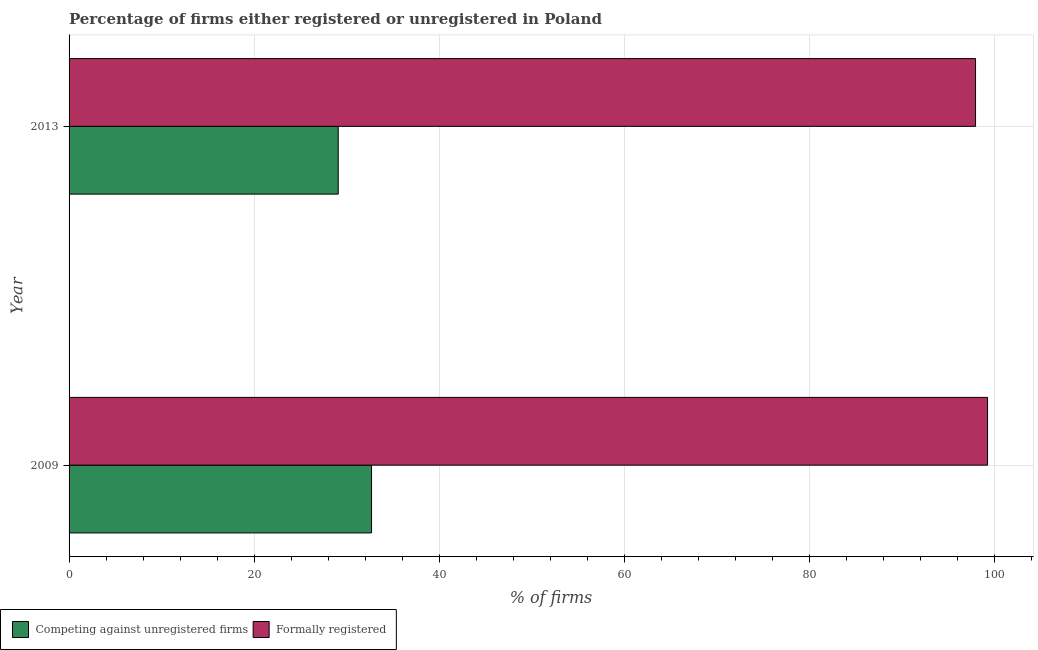How many different coloured bars are there?
Offer a terse response. 2. Are the number of bars on each tick of the Y-axis equal?
Offer a very short reply. Yes. How many bars are there on the 2nd tick from the top?
Your answer should be compact. 2. How many bars are there on the 1st tick from the bottom?
Your response must be concise. 2. In how many cases, is the number of bars for a given year not equal to the number of legend labels?
Provide a short and direct response. 0. What is the percentage of formally registered firms in 2009?
Offer a terse response. 99.3. Across all years, what is the maximum percentage of formally registered firms?
Offer a terse response. 99.3. In which year was the percentage of formally registered firms maximum?
Give a very brief answer. 2009. In which year was the percentage of formally registered firms minimum?
Keep it short and to the point. 2013. What is the total percentage of registered firms in the graph?
Make the answer very short. 61.8. What is the difference between the percentage of formally registered firms in 2009 and that in 2013?
Your answer should be very brief. 1.3. What is the difference between the percentage of formally registered firms in 2009 and the percentage of registered firms in 2013?
Your response must be concise. 70.2. What is the average percentage of formally registered firms per year?
Keep it short and to the point. 98.65. In the year 2009, what is the difference between the percentage of formally registered firms and percentage of registered firms?
Offer a terse response. 66.6. In how many years, is the percentage of formally registered firms greater than 64 %?
Give a very brief answer. 2. What is the ratio of the percentage of registered firms in 2009 to that in 2013?
Your answer should be compact. 1.12. What does the 1st bar from the top in 2013 represents?
Offer a terse response. Formally registered. What does the 2nd bar from the bottom in 2013 represents?
Offer a terse response. Formally registered. How many bars are there?
Keep it short and to the point. 4. Are all the bars in the graph horizontal?
Your answer should be very brief. Yes. What is the difference between two consecutive major ticks on the X-axis?
Give a very brief answer. 20. Does the graph contain grids?
Ensure brevity in your answer.  Yes. What is the title of the graph?
Your response must be concise. Percentage of firms either registered or unregistered in Poland. Does "Under-5(female)" appear as one of the legend labels in the graph?
Your answer should be compact. No. What is the label or title of the X-axis?
Provide a short and direct response. % of firms. What is the label or title of the Y-axis?
Keep it short and to the point. Year. What is the % of firms in Competing against unregistered firms in 2009?
Keep it short and to the point. 32.7. What is the % of firms in Formally registered in 2009?
Your answer should be compact. 99.3. What is the % of firms in Competing against unregistered firms in 2013?
Offer a very short reply. 29.1. Across all years, what is the maximum % of firms of Competing against unregistered firms?
Provide a short and direct response. 32.7. Across all years, what is the maximum % of firms in Formally registered?
Provide a short and direct response. 99.3. Across all years, what is the minimum % of firms of Competing against unregistered firms?
Offer a very short reply. 29.1. What is the total % of firms in Competing against unregistered firms in the graph?
Offer a very short reply. 61.8. What is the total % of firms of Formally registered in the graph?
Give a very brief answer. 197.3. What is the difference between the % of firms in Competing against unregistered firms in 2009 and that in 2013?
Your answer should be compact. 3.6. What is the difference between the % of firms in Competing against unregistered firms in 2009 and the % of firms in Formally registered in 2013?
Provide a short and direct response. -65.3. What is the average % of firms in Competing against unregistered firms per year?
Ensure brevity in your answer.  30.9. What is the average % of firms in Formally registered per year?
Your answer should be compact. 98.65. In the year 2009, what is the difference between the % of firms in Competing against unregistered firms and % of firms in Formally registered?
Make the answer very short. -66.6. In the year 2013, what is the difference between the % of firms in Competing against unregistered firms and % of firms in Formally registered?
Your answer should be compact. -68.9. What is the ratio of the % of firms of Competing against unregistered firms in 2009 to that in 2013?
Make the answer very short. 1.12. What is the ratio of the % of firms in Formally registered in 2009 to that in 2013?
Your response must be concise. 1.01. 